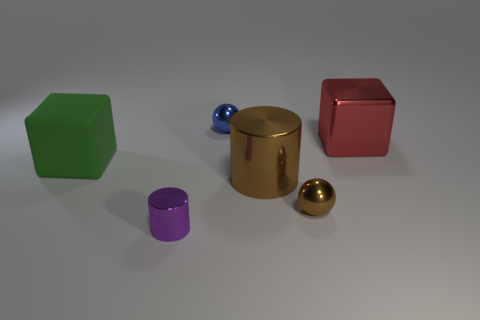Add 1 shiny cylinders. How many objects exist? 7 Subtract 1 cubes. How many cubes are left? 1 Subtract all spheres. How many objects are left? 4 Subtract all green blocks. How many purple cylinders are left? 1 Subtract all tiny metal balls. Subtract all big metallic cubes. How many objects are left? 3 Add 5 rubber objects. How many rubber objects are left? 6 Add 1 brown metal objects. How many brown metal objects exist? 3 Subtract 0 purple blocks. How many objects are left? 6 Subtract all purple cylinders. Subtract all cyan blocks. How many cylinders are left? 1 